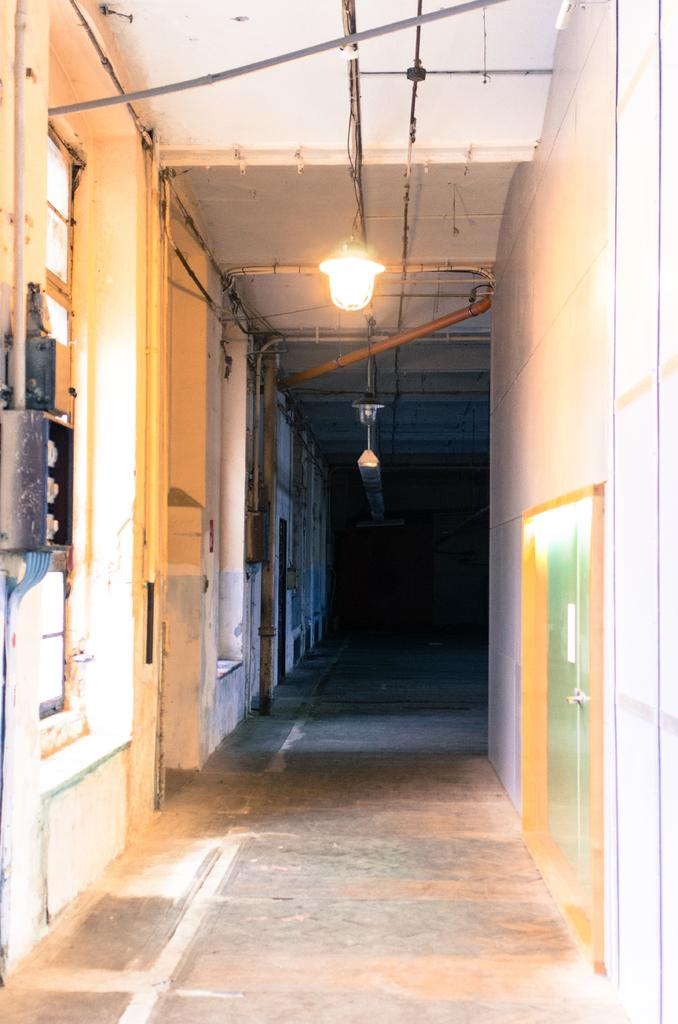What can be seen hanging in the image? There are lights hanging in the image. What type of structures are present in the image? There are walls in the image. What color are the objects on the left side of the image? The objects on the left side of the image are grey and black in color. What is located at the top of the image? There are pipes on the top of the image. What type of airport is visible in the image? There is no airport present in the image. What relation do the objects on the left side of the image have to each other? The objects on the left side of the image do not have a visible relation to each other in the image. 